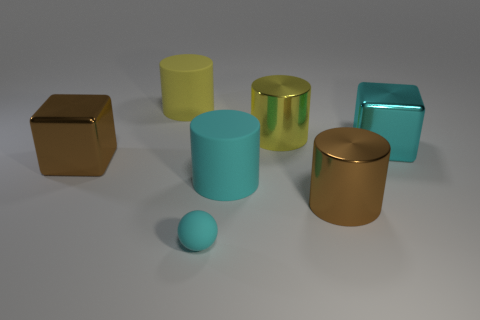Is the size of the yellow matte object the same as the rubber ball?
Provide a short and direct response. No. Does the shiny cylinder in front of the cyan rubber cylinder have the same size as the tiny cyan sphere?
Your response must be concise. No. There is a cyan object that is the same size as the cyan shiny block; what material is it?
Your answer should be very brief. Rubber. Are there any rubber cylinders behind the large cube that is right of the cylinder that is on the left side of the tiny cyan matte sphere?
Make the answer very short. Yes. Is there anything else that has the same shape as the small matte object?
Ensure brevity in your answer.  No. Is the color of the large cube that is left of the tiny cyan sphere the same as the big metallic cylinder that is in front of the big cyan shiny thing?
Provide a succinct answer. Yes. Are there any small green balls?
Offer a terse response. No. There is a cylinder that is the same color as the tiny rubber sphere; what material is it?
Your answer should be very brief. Rubber. How big is the shiny thing behind the big cyan thing on the right side of the big yellow thing that is on the right side of the yellow rubber cylinder?
Provide a short and direct response. Large. There is a big yellow shiny object; does it have the same shape as the big matte thing that is on the right side of the large yellow matte cylinder?
Your response must be concise. Yes. 